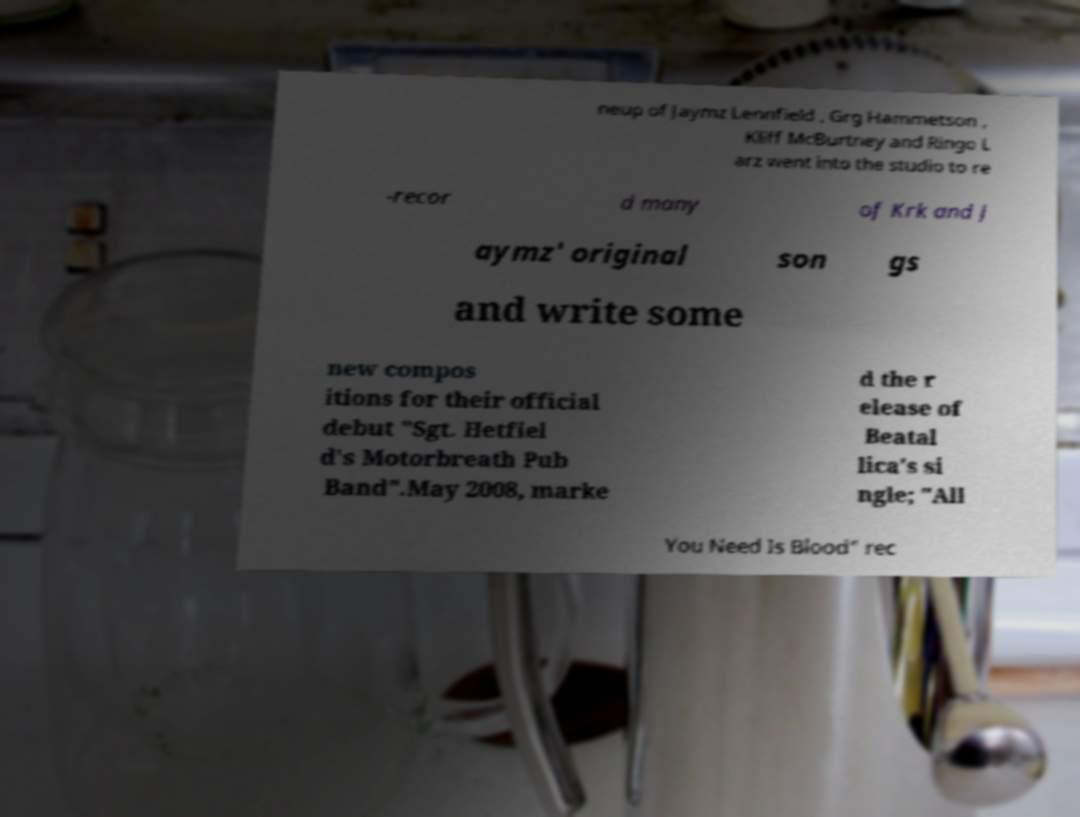Please identify and transcribe the text found in this image. neup of Jaymz Lennfield , Grg Hammetson , Kliff McBurtney and Ringo L arz went into the studio to re -recor d many of Krk and J aymz' original son gs and write some new compos itions for their official debut "Sgt. Hetfiel d's Motorbreath Pub Band".May 2008, marke d the r elease of Beatal lica's si ngle; "All You Need Is Blood" rec 